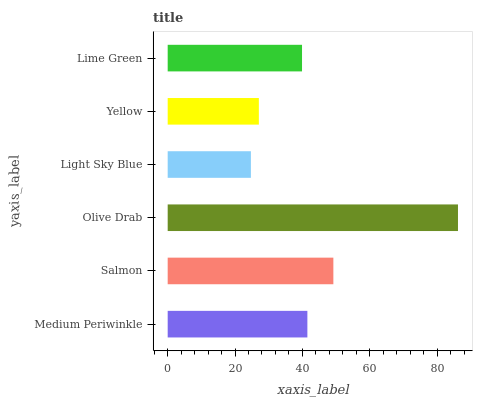Is Light Sky Blue the minimum?
Answer yes or no. Yes. Is Olive Drab the maximum?
Answer yes or no. Yes. Is Salmon the minimum?
Answer yes or no. No. Is Salmon the maximum?
Answer yes or no. No. Is Salmon greater than Medium Periwinkle?
Answer yes or no. Yes. Is Medium Periwinkle less than Salmon?
Answer yes or no. Yes. Is Medium Periwinkle greater than Salmon?
Answer yes or no. No. Is Salmon less than Medium Periwinkle?
Answer yes or no. No. Is Medium Periwinkle the high median?
Answer yes or no. Yes. Is Lime Green the low median?
Answer yes or no. Yes. Is Yellow the high median?
Answer yes or no. No. Is Yellow the low median?
Answer yes or no. No. 